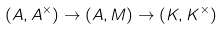<formula> <loc_0><loc_0><loc_500><loc_500>( A , A ^ { \times } ) \to ( A , M ) \to ( K , K ^ { \times } )</formula> 